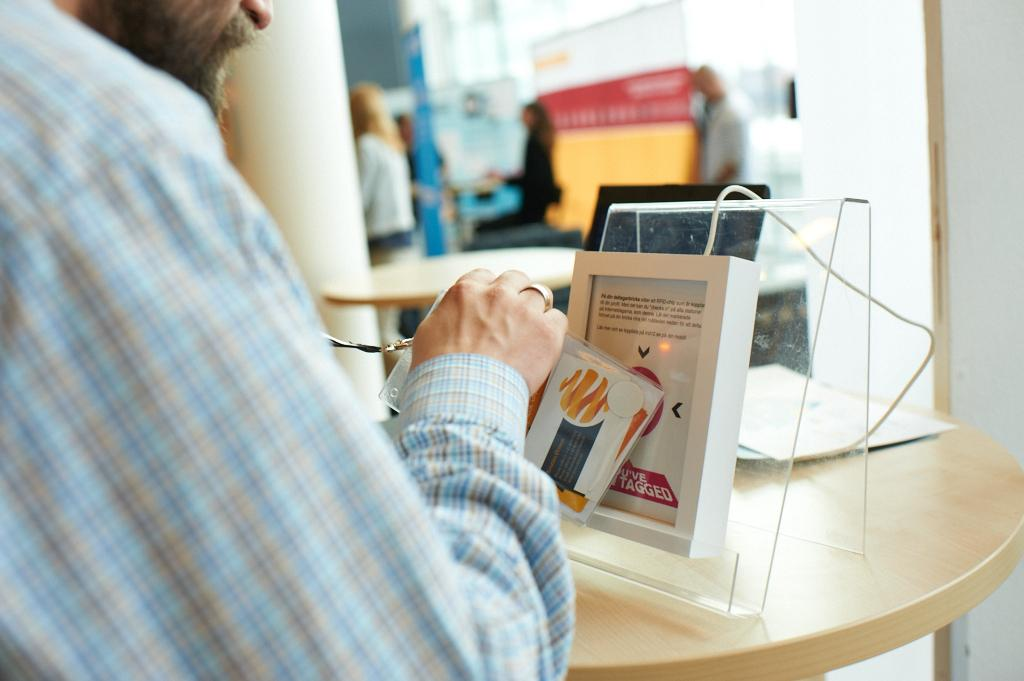Who is present in the image? There is a man in the image. What is the man holding in the image? The man is holding an ID card. What can be seen on the table in the image? There is electronic equipment and papers on the table. Can you describe the background of the image? There are blurred people in the background of the image. What type of lace can be seen on the man's clothing in the image? There is no lace visible on the man's clothing in the image. Is there any snow present in the image? There is no snow present in the image. 